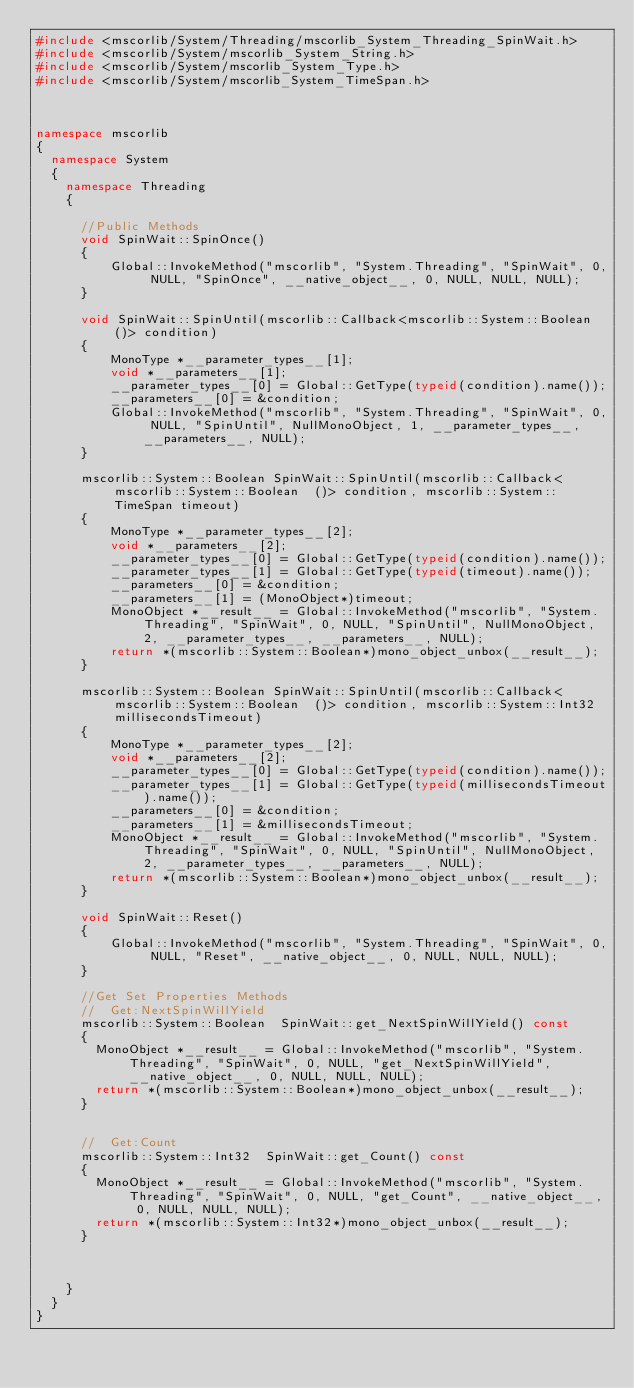<code> <loc_0><loc_0><loc_500><loc_500><_C++_>#include <mscorlib/System/Threading/mscorlib_System_Threading_SpinWait.h>
#include <mscorlib/System/mscorlib_System_String.h>
#include <mscorlib/System/mscorlib_System_Type.h>
#include <mscorlib/System/mscorlib_System_TimeSpan.h>



namespace mscorlib
{
	namespace System
	{
		namespace Threading
		{

			//Public Methods
			void SpinWait::SpinOnce()
			{
					Global::InvokeMethod("mscorlib", "System.Threading", "SpinWait", 0, NULL, "SpinOnce", __native_object__, 0, NULL, NULL, NULL);
			}

			void SpinWait::SpinUntil(mscorlib::Callback<mscorlib::System::Boolean  ()> condition)
			{
					MonoType *__parameter_types__[1];
					void *__parameters__[1];
					__parameter_types__[0] = Global::GetType(typeid(condition).name());
					__parameters__[0] = &condition;
					Global::InvokeMethod("mscorlib", "System.Threading", "SpinWait", 0, NULL, "SpinUntil", NullMonoObject, 1, __parameter_types__, __parameters__, NULL);
			}

			mscorlib::System::Boolean SpinWait::SpinUntil(mscorlib::Callback<mscorlib::System::Boolean  ()> condition, mscorlib::System::TimeSpan timeout)
			{
					MonoType *__parameter_types__[2];
					void *__parameters__[2];
					__parameter_types__[0] = Global::GetType(typeid(condition).name());
					__parameter_types__[1] = Global::GetType(typeid(timeout).name());
					__parameters__[0] = &condition;
					__parameters__[1] = (MonoObject*)timeout;
					MonoObject *__result__ = Global::InvokeMethod("mscorlib", "System.Threading", "SpinWait", 0, NULL, "SpinUntil", NullMonoObject, 2, __parameter_types__, __parameters__, NULL);
					return *(mscorlib::System::Boolean*)mono_object_unbox(__result__);
			}

			mscorlib::System::Boolean SpinWait::SpinUntil(mscorlib::Callback<mscorlib::System::Boolean  ()> condition, mscorlib::System::Int32 millisecondsTimeout)
			{
					MonoType *__parameter_types__[2];
					void *__parameters__[2];
					__parameter_types__[0] = Global::GetType(typeid(condition).name());
					__parameter_types__[1] = Global::GetType(typeid(millisecondsTimeout).name());
					__parameters__[0] = &condition;
					__parameters__[1] = &millisecondsTimeout;
					MonoObject *__result__ = Global::InvokeMethod("mscorlib", "System.Threading", "SpinWait", 0, NULL, "SpinUntil", NullMonoObject, 2, __parameter_types__, __parameters__, NULL);
					return *(mscorlib::System::Boolean*)mono_object_unbox(__result__);
			}

			void SpinWait::Reset()
			{
					Global::InvokeMethod("mscorlib", "System.Threading", "SpinWait", 0, NULL, "Reset", __native_object__, 0, NULL, NULL, NULL);
			}

			//Get Set Properties Methods
			//	Get:NextSpinWillYield
			mscorlib::System::Boolean  SpinWait::get_NextSpinWillYield() const
			{
				MonoObject *__result__ = Global::InvokeMethod("mscorlib", "System.Threading", "SpinWait", 0, NULL, "get_NextSpinWillYield", __native_object__, 0, NULL, NULL, NULL);
				return *(mscorlib::System::Boolean*)mono_object_unbox(__result__);
			}


			//	Get:Count
			mscorlib::System::Int32  SpinWait::get_Count() const
			{
				MonoObject *__result__ = Global::InvokeMethod("mscorlib", "System.Threading", "SpinWait", 0, NULL, "get_Count", __native_object__, 0, NULL, NULL, NULL);
				return *(mscorlib::System::Int32*)mono_object_unbox(__result__);
			}



		}
	}
}
</code> 